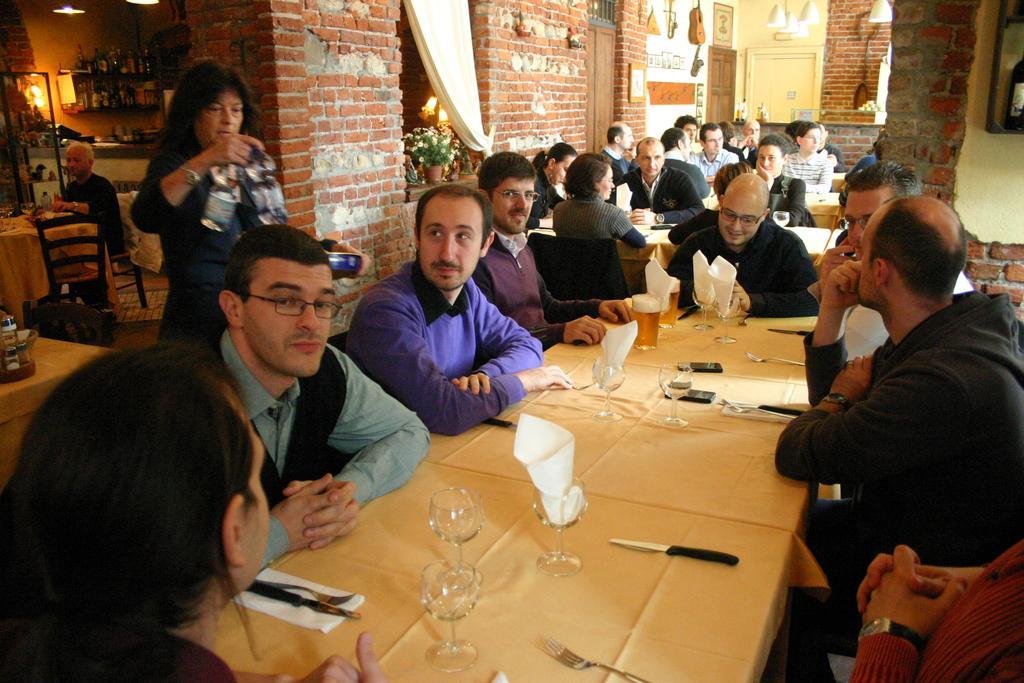In one or two sentences, can you explain what this image depicts? In this picture we can see a group of people sitting in front of a dining table, behind them there is a woman standing and holding water bottles, in the background we can see a brick wall, there are some plants here, in the dining table we can see some empty glasses, one knife and tissue papers, on the left side of the picture we can see a person sitting on chair and also we can see some bottles here. 